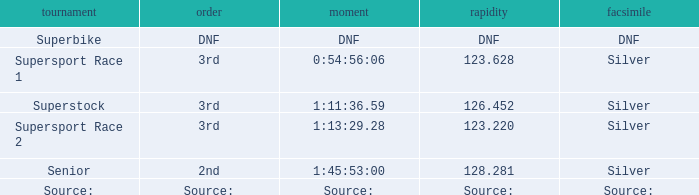Which race has a replica of DNF? Superbike. 